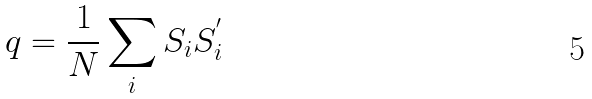Convert formula to latex. <formula><loc_0><loc_0><loc_500><loc_500>q = \frac { 1 } { N } \sum _ { i } S _ { i } S _ { i } ^ { ^ { \prime } }</formula> 